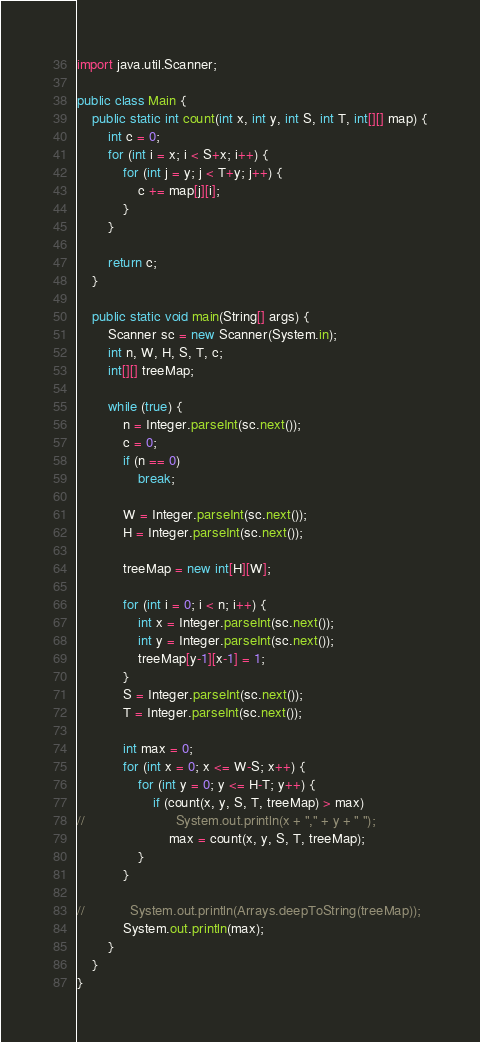<code> <loc_0><loc_0><loc_500><loc_500><_Java_>import java.util.Scanner;

public class Main {
    public static int count(int x, int y, int S, int T, int[][] map) {
        int c = 0;
        for (int i = x; i < S+x; i++) {
            for (int j = y; j < T+y; j++) {
                c += map[j][i];
            }
        }

        return c;
    }

    public static void main(String[] args) {
        Scanner sc = new Scanner(System.in);
        int n, W, H, S, T, c;
        int[][] treeMap;

        while (true) {
            n = Integer.parseInt(sc.next());
            c = 0;
            if (n == 0)
                break;

            W = Integer.parseInt(sc.next());
            H = Integer.parseInt(sc.next());

            treeMap = new int[H][W];

            for (int i = 0; i < n; i++) {
                int x = Integer.parseInt(sc.next());
                int y = Integer.parseInt(sc.next());
                treeMap[y-1][x-1] = 1;
            }
            S = Integer.parseInt(sc.next());
            T = Integer.parseInt(sc.next());

            int max = 0;
            for (int x = 0; x <= W-S; x++) {
                for (int y = 0; y <= H-T; y++) {
                    if (count(x, y, S, T, treeMap) > max)
//                        System.out.println(x + "," + y + " ");
                        max = count(x, y, S, T, treeMap);
                }
            }

//            System.out.println(Arrays.deepToString(treeMap));
            System.out.println(max);
        }
    }
}</code> 